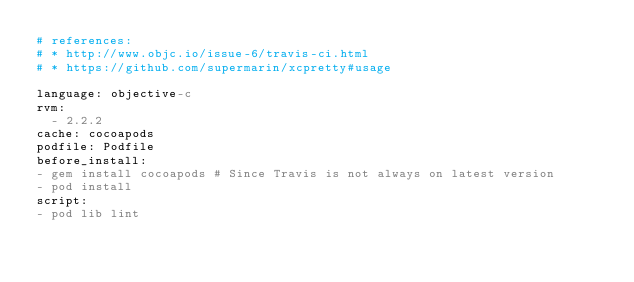<code> <loc_0><loc_0><loc_500><loc_500><_YAML_># references:
# * http://www.objc.io/issue-6/travis-ci.html
# * https://github.com/supermarin/xcpretty#usage

language: objective-c
rvm:
  - 2.2.2
cache: cocoapods
podfile: Podfile
before_install:
- gem install cocoapods # Since Travis is not always on latest version
- pod install
script:
- pod lib lint
</code> 